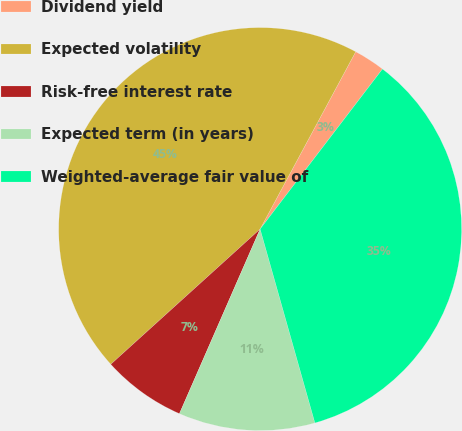<chart> <loc_0><loc_0><loc_500><loc_500><pie_chart><fcel>Dividend yield<fcel>Expected volatility<fcel>Risk-free interest rate<fcel>Expected term (in years)<fcel>Weighted-average fair value of<nl><fcel>2.52%<fcel>44.58%<fcel>6.73%<fcel>10.94%<fcel>35.23%<nl></chart> 